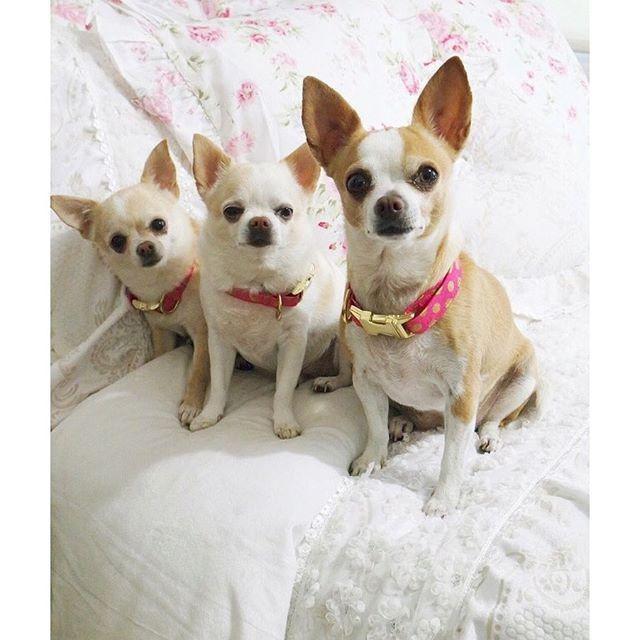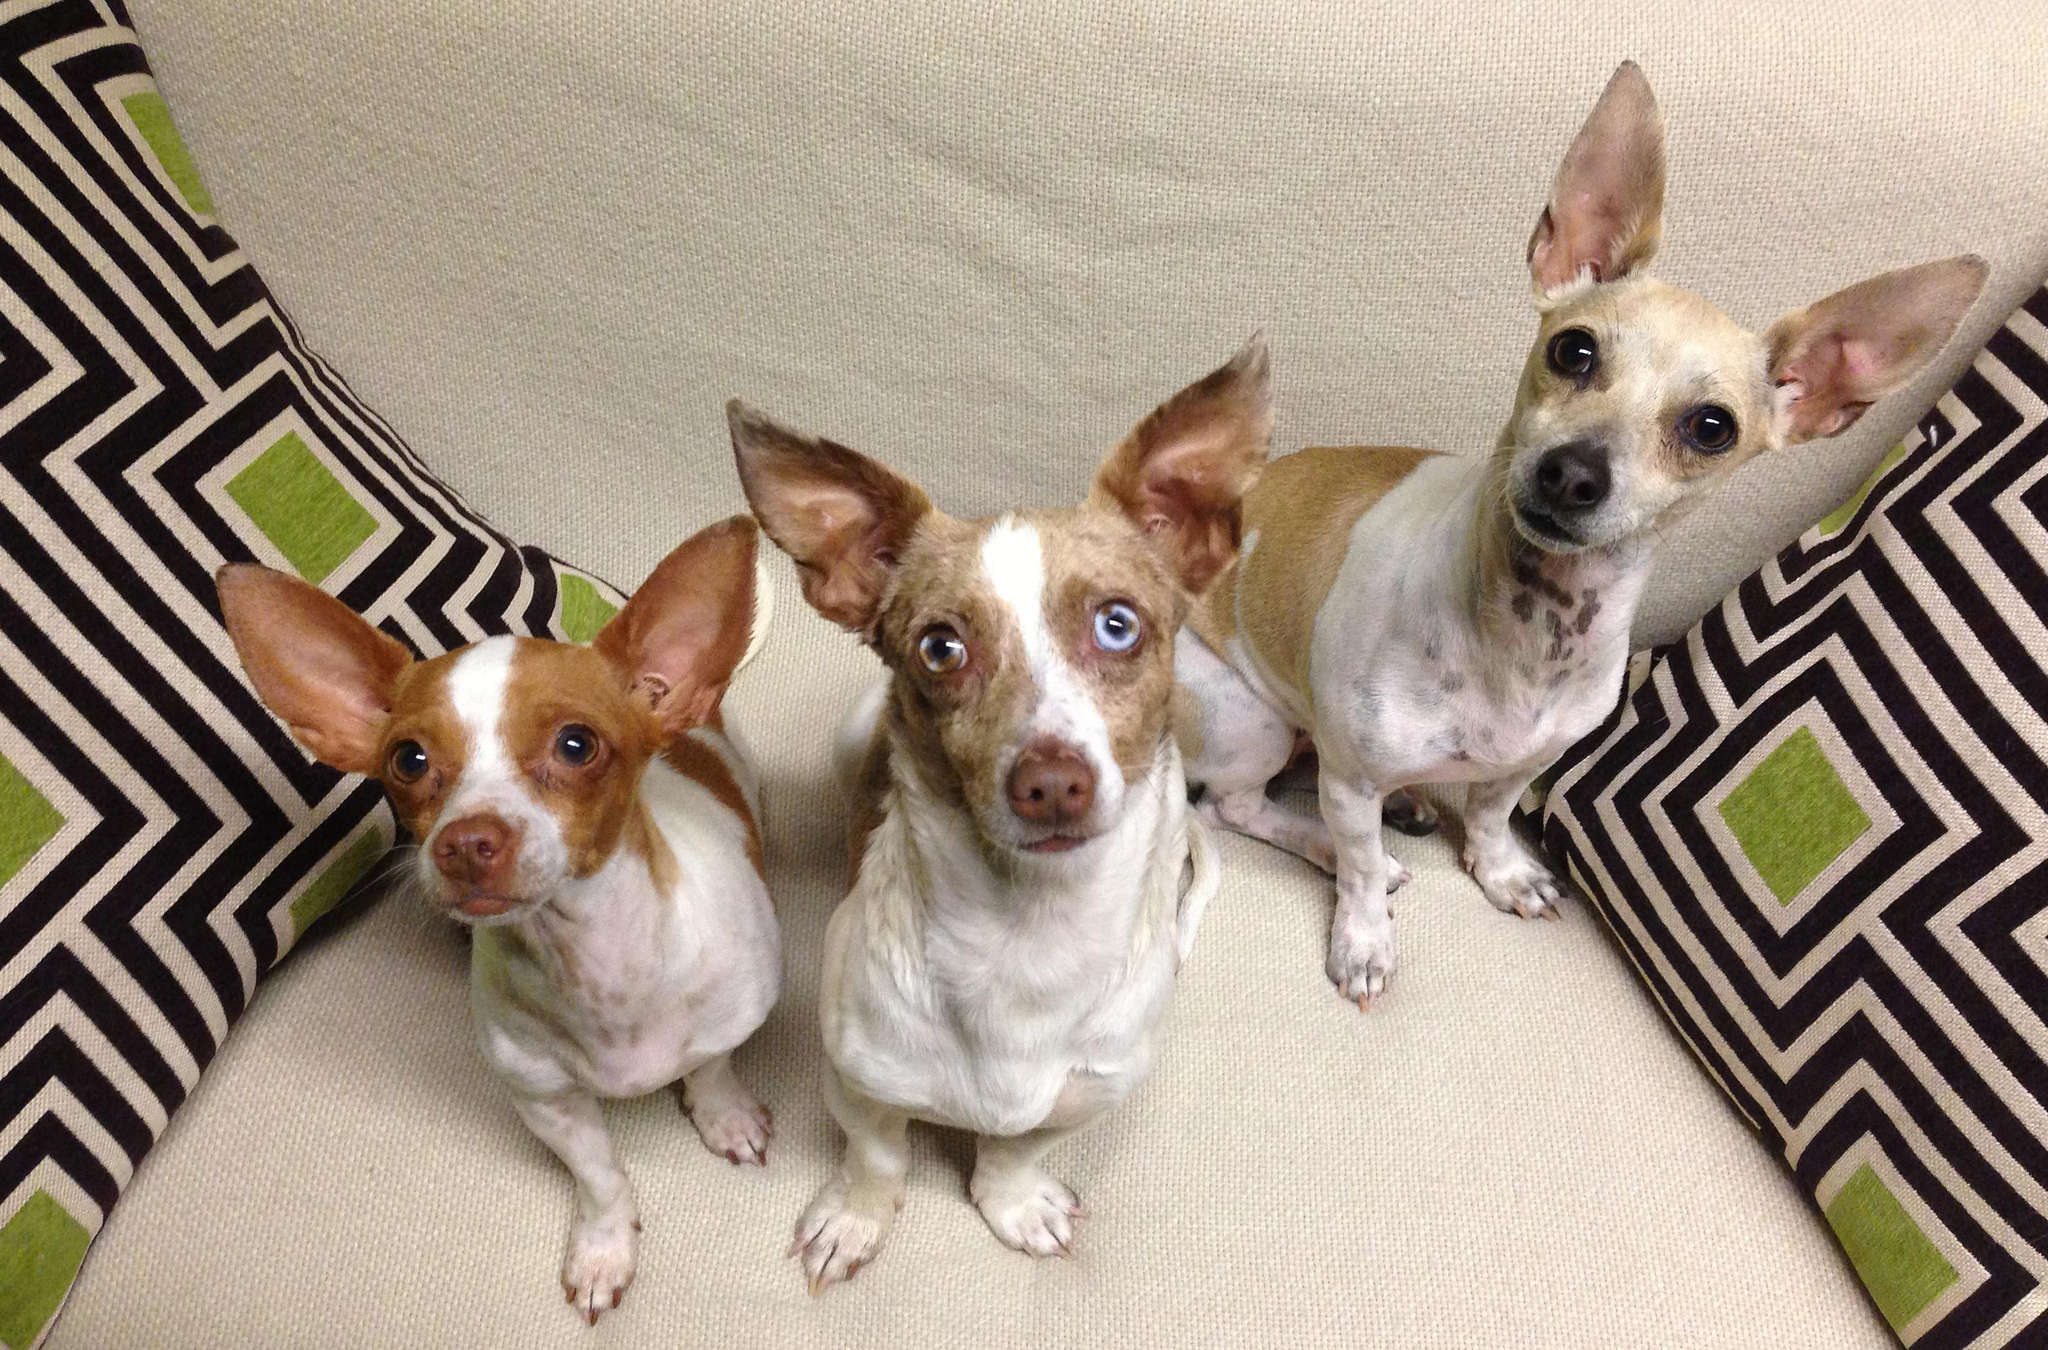The first image is the image on the left, the second image is the image on the right. Given the left and right images, does the statement "There are three chihuahuas in the right image." hold true? Answer yes or no. Yes. The first image is the image on the left, the second image is the image on the right. Assess this claim about the two images: "Each image contains three dogs, and one set of dogs pose wearing only collars.". Correct or not? Answer yes or no. Yes. 